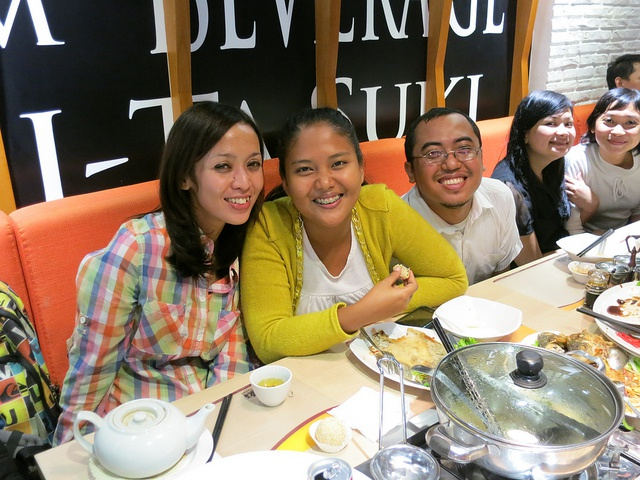Describe the objects in this image and their specific colors. I can see dining table in navy, ivory, darkgray, beige, and gray tones, people in navy, black, brown, darkgray, and tan tones, people in navy, olive, gold, and salmon tones, bowl in navy, darkgray, lightgray, and gray tones, and people in navy, brown, lightgray, darkgray, and maroon tones in this image. 